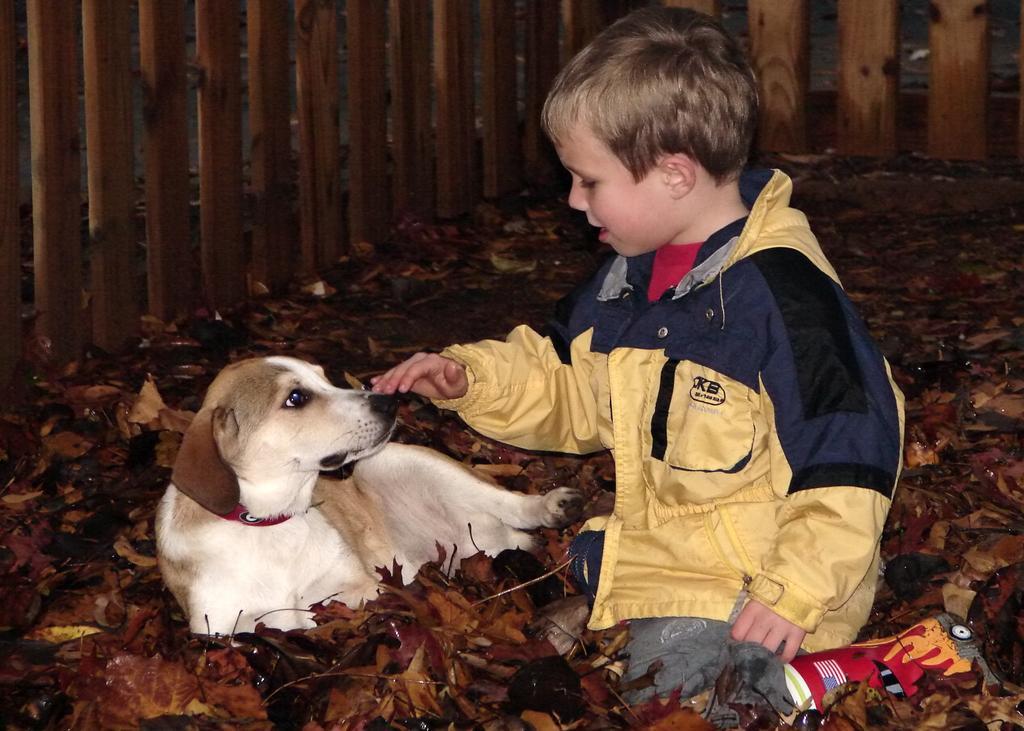Please provide a concise description of this image. In this picture, a boy who wearing a yellow jacket. He is sitting on the floor beside the white dogs. On the floor we can see a lots of leafs. On the top there is a wooden fencing. This boy touching the nose of a dog. 